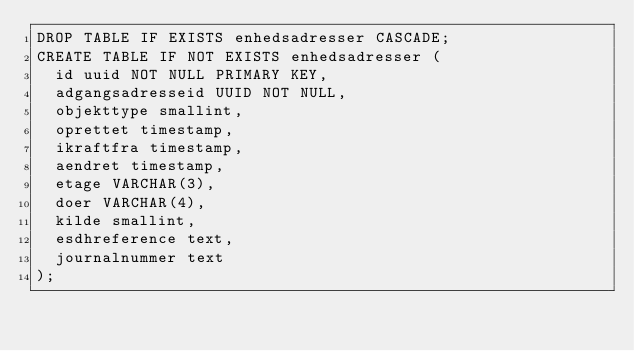<code> <loc_0><loc_0><loc_500><loc_500><_SQL_>DROP TABLE IF EXISTS enhedsadresser CASCADE;
CREATE TABLE IF NOT EXISTS enhedsadresser (
  id uuid NOT NULL PRIMARY KEY,
  adgangsadresseid UUID NOT NULL,
  objekttype smallint,
  oprettet timestamp,
  ikraftfra timestamp,
  aendret timestamp,
  etage VARCHAR(3),
  doer VARCHAR(4),
  kilde smallint,
  esdhreference text,
  journalnummer text
);
</code> 